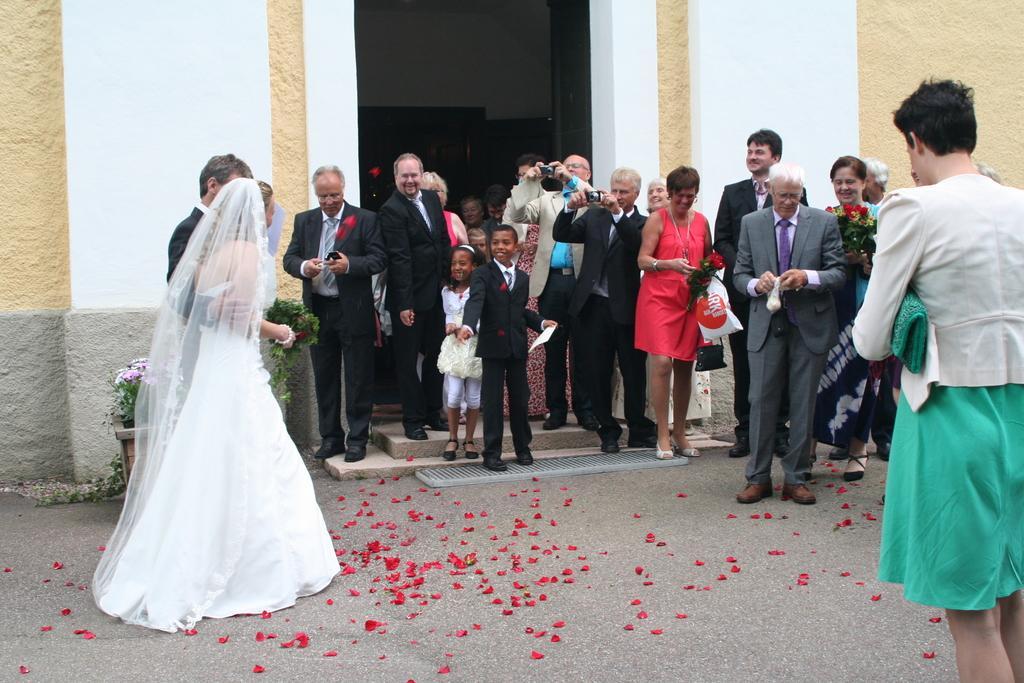Can you describe this image briefly? Here people are standing, these are flowers, this is plant, this is wall. 